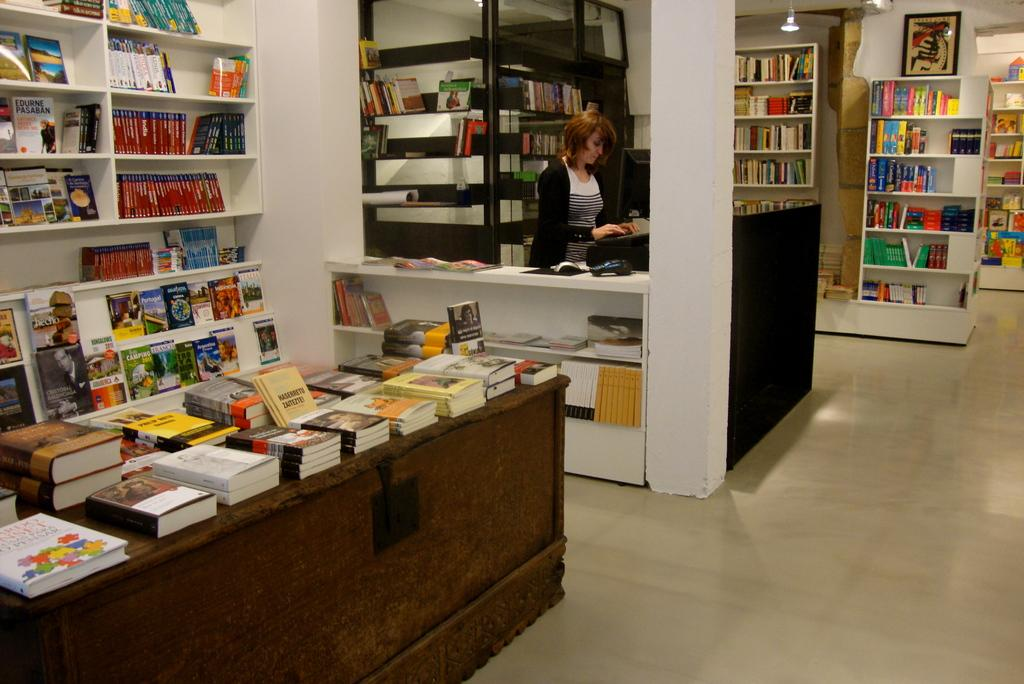What type of establishment is depicted in the image? There is a store in the image. What can be found inside the store? The store contains different kinds of books. How are the books organized in the store? The books are arranged in cupboards. Is there anyone present in the store? Yes, there is a woman standing in the store. What type of rice is being sold in the store? There is no rice present in the image; the store contains different kinds of books. Can you see the woman's teeth in the image? The image does not show the woman's teeth; it only shows her standing in the store. 